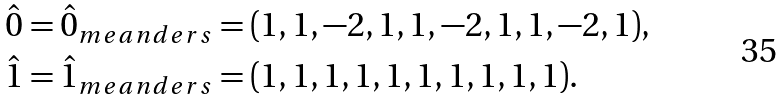<formula> <loc_0><loc_0><loc_500><loc_500>\hat { 0 } = \hat { 0 } _ { m e a n d e r s } & = ( 1 , 1 , - 2 , 1 , 1 , - 2 , 1 , 1 , - 2 , 1 ) , \\ \hat { 1 } = \hat { 1 } _ { m e a n d e r s } & = ( 1 , 1 , 1 , 1 , 1 , 1 , 1 , 1 , 1 , 1 ) .</formula> 